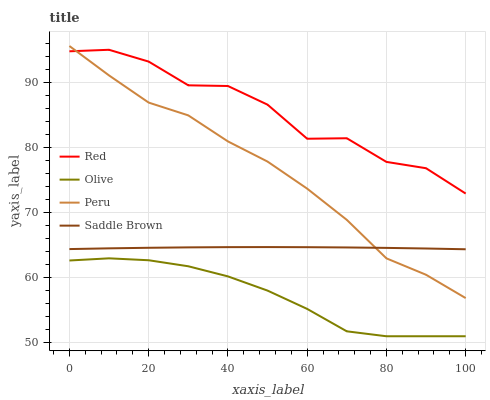Does Olive have the minimum area under the curve?
Answer yes or no. Yes. Does Red have the maximum area under the curve?
Answer yes or no. Yes. Does Peru have the minimum area under the curve?
Answer yes or no. No. Does Peru have the maximum area under the curve?
Answer yes or no. No. Is Saddle Brown the smoothest?
Answer yes or no. Yes. Is Red the roughest?
Answer yes or no. Yes. Is Peru the smoothest?
Answer yes or no. No. Is Peru the roughest?
Answer yes or no. No. Does Olive have the lowest value?
Answer yes or no. Yes. Does Peru have the lowest value?
Answer yes or no. No. Does Peru have the highest value?
Answer yes or no. Yes. Does Red have the highest value?
Answer yes or no. No. Is Saddle Brown less than Red?
Answer yes or no. Yes. Is Red greater than Olive?
Answer yes or no. Yes. Does Peru intersect Red?
Answer yes or no. Yes. Is Peru less than Red?
Answer yes or no. No. Is Peru greater than Red?
Answer yes or no. No. Does Saddle Brown intersect Red?
Answer yes or no. No. 